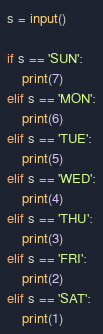<code> <loc_0><loc_0><loc_500><loc_500><_Python_>s = input()

if s == 'SUN':
    print(7)
elif s == 'MON':
    print(6)
elif s == 'TUE':
    print(5)
elif s == 'WED':
    print(4)
elif s == 'THU':
    print(3)
elif s == 'FRI':
    print(2)
elif s == 'SAT':
    print(1)
</code> 